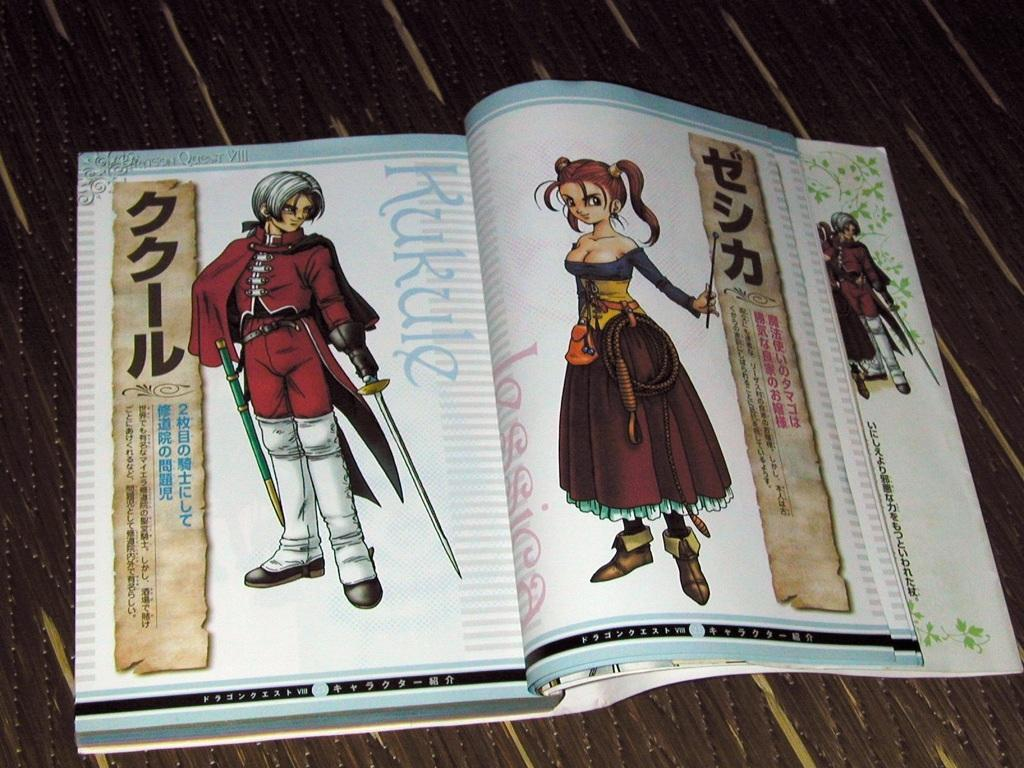<image>
Write a terse but informative summary of the picture. An open Japanese or chinese book with symbols and the word Kukule written close to the inside binder. 